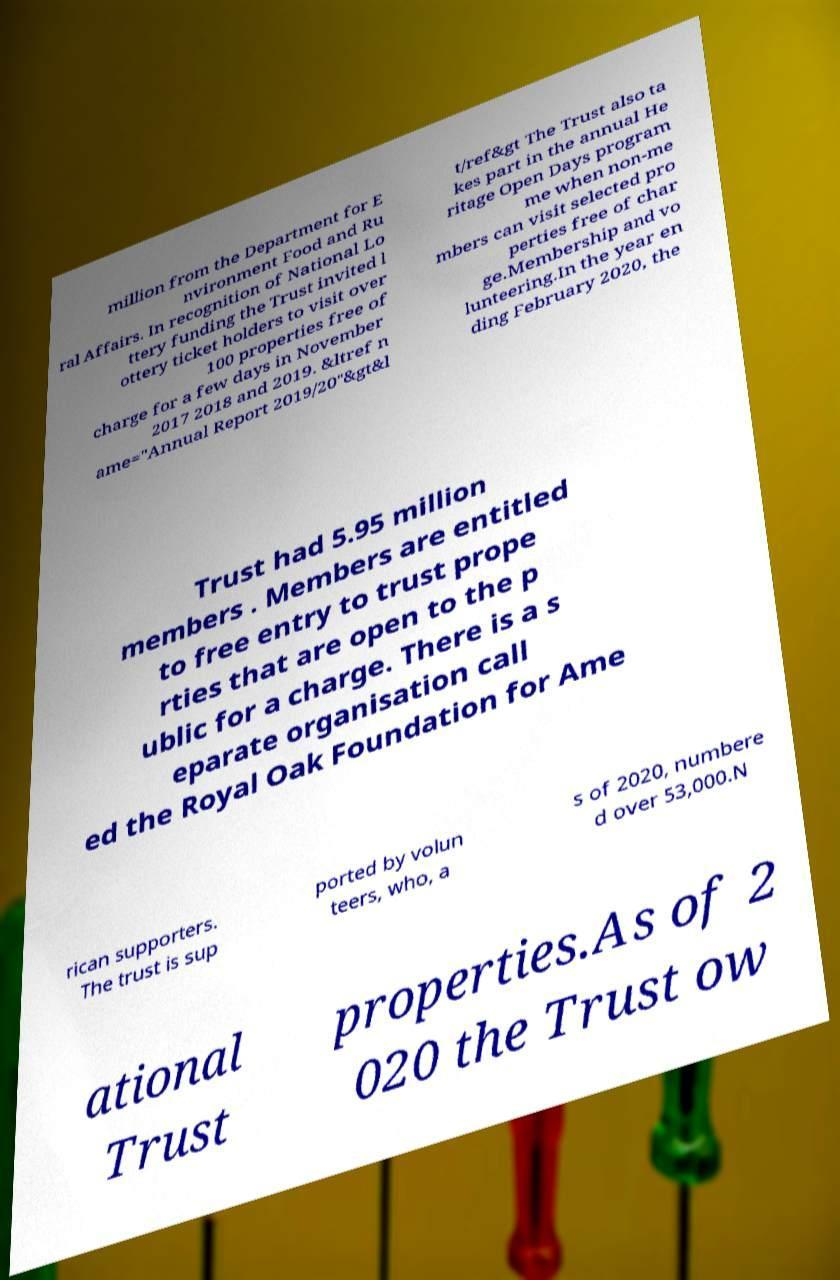Could you assist in decoding the text presented in this image and type it out clearly? million from the Department for E nvironment Food and Ru ral Affairs. In recognition of National Lo ttery funding the Trust invited l ottery ticket holders to visit over 100 properties free of charge for a few days in November 2017 2018 and 2019. &ltref n ame="Annual Report 2019/20"&gt&l t/ref&gt The Trust also ta kes part in the annual He ritage Open Days program me when non-me mbers can visit selected pro perties free of char ge.Membership and vo lunteering.In the year en ding February 2020, the Trust had 5.95 million members . Members are entitled to free entry to trust prope rties that are open to the p ublic for a charge. There is a s eparate organisation call ed the Royal Oak Foundation for Ame rican supporters. The trust is sup ported by volun teers, who, a s of 2020, numbere d over 53,000.N ational Trust properties.As of 2 020 the Trust ow 